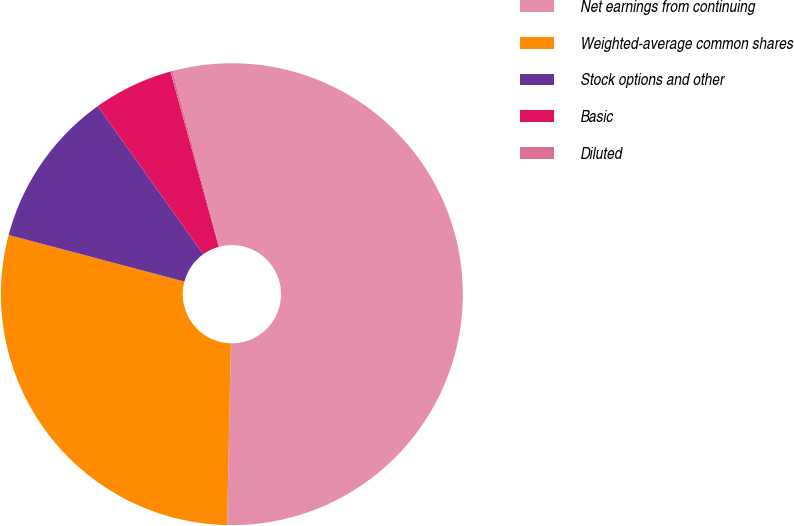<chart> <loc_0><loc_0><loc_500><loc_500><pie_chart><fcel>Net earnings from continuing<fcel>Weighted-average common shares<fcel>Stock options and other<fcel>Basic<fcel>Diluted<nl><fcel>54.44%<fcel>28.8%<fcel>11.01%<fcel>5.58%<fcel>0.16%<nl></chart> 